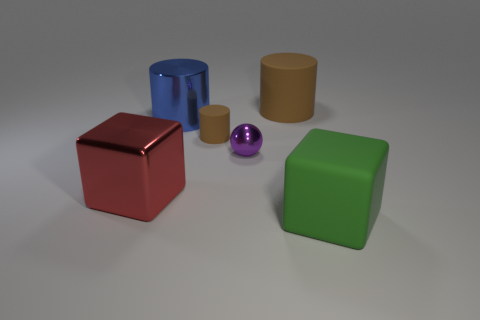How are the shadows behaving in this image? The shadows in the image indicate a light source coming from the upper left, as they are cast toward the right side of the objects. All objects have well-defined shadows, suggesting the light source is strong and possibly singular. 